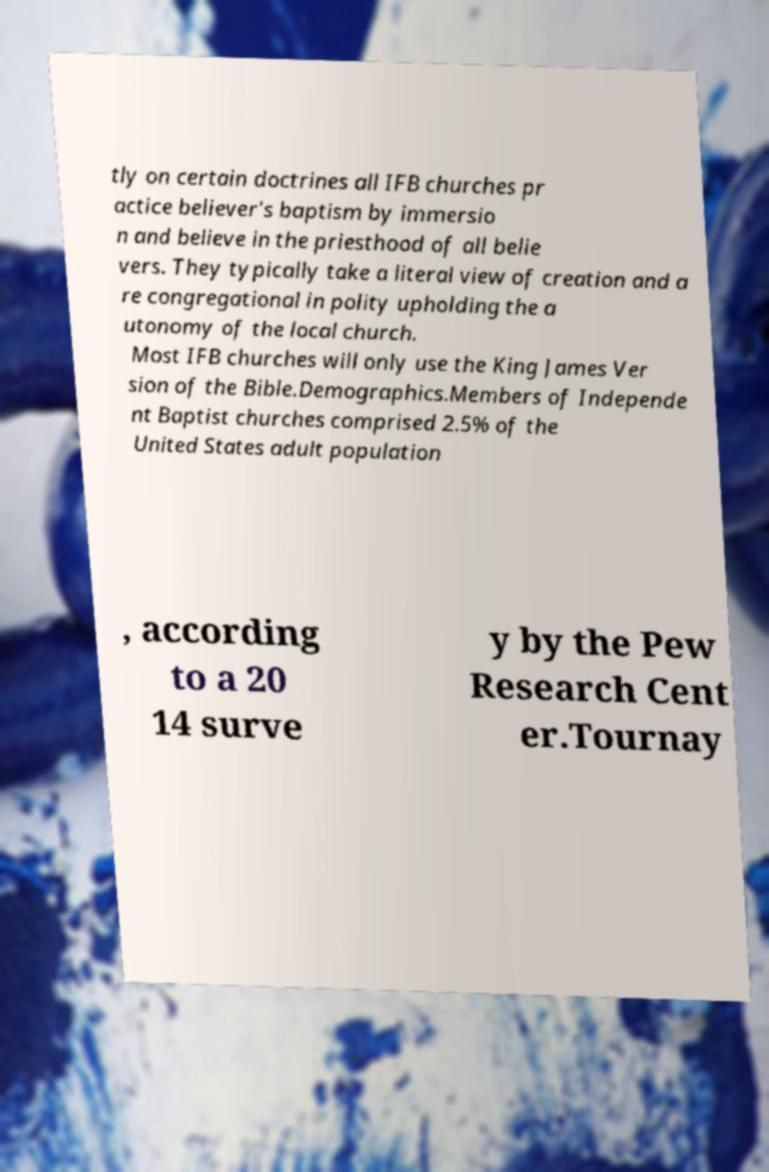What messages or text are displayed in this image? I need them in a readable, typed format. tly on certain doctrines all IFB churches pr actice believer's baptism by immersio n and believe in the priesthood of all belie vers. They typically take a literal view of creation and a re congregational in polity upholding the a utonomy of the local church. Most IFB churches will only use the King James Ver sion of the Bible.Demographics.Members of Independe nt Baptist churches comprised 2.5% of the United States adult population , according to a 20 14 surve y by the Pew Research Cent er.Tournay 